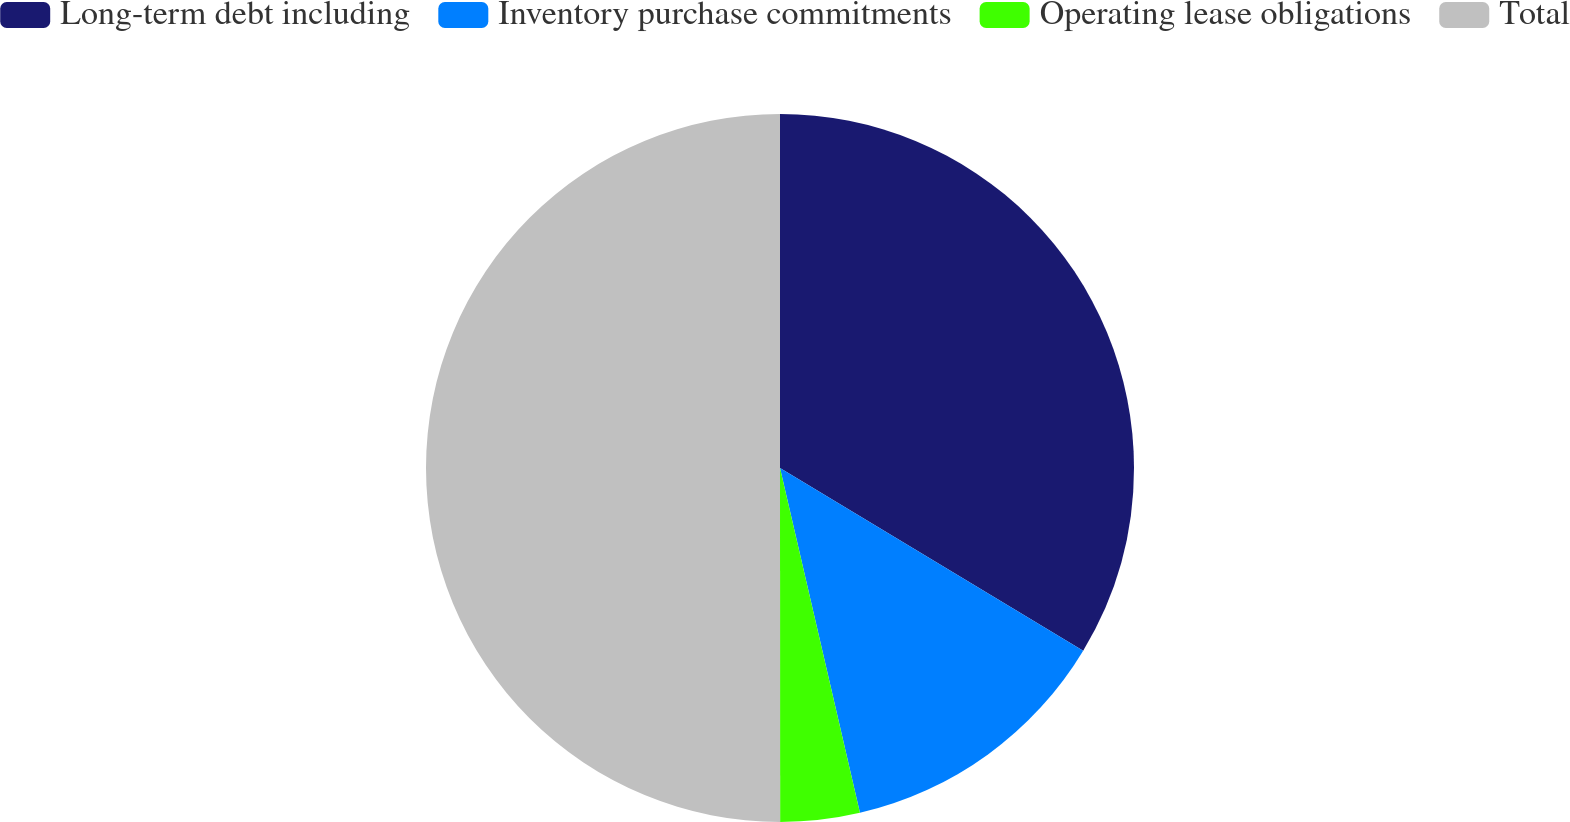<chart> <loc_0><loc_0><loc_500><loc_500><pie_chart><fcel>Long-term debt including<fcel>Inventory purchase commitments<fcel>Operating lease obligations<fcel>Total<nl><fcel>33.63%<fcel>12.74%<fcel>3.62%<fcel>50.0%<nl></chart> 